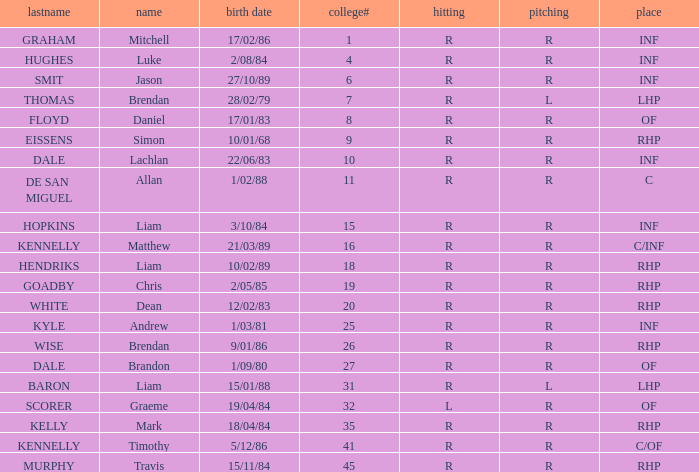Which player has a last name of baron? R. 